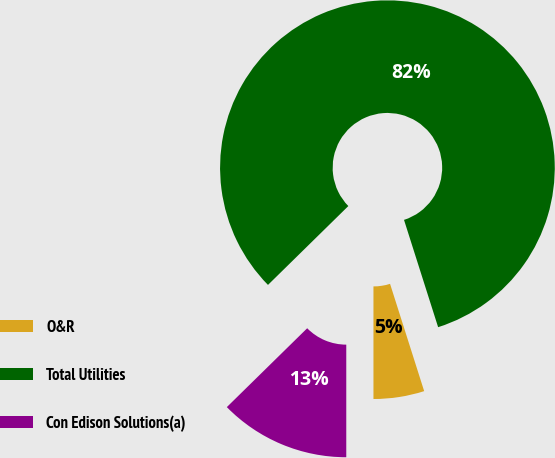Convert chart to OTSL. <chart><loc_0><loc_0><loc_500><loc_500><pie_chart><fcel>O&R<fcel>Total Utilities<fcel>Con Edison Solutions(a)<nl><fcel>4.9%<fcel>82.45%<fcel>12.65%<nl></chart> 